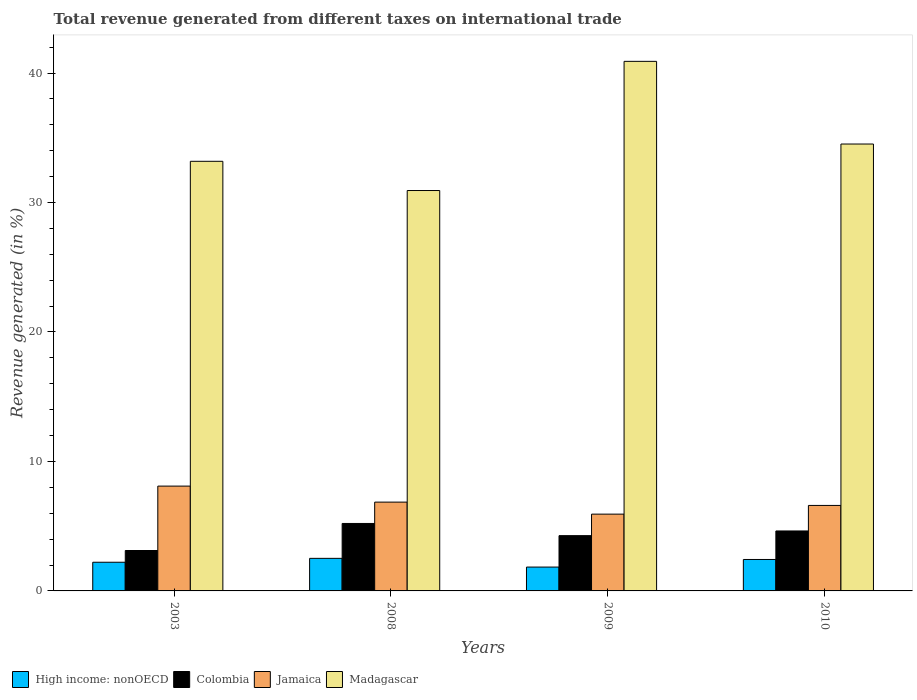How many groups of bars are there?
Keep it short and to the point. 4. Are the number of bars on each tick of the X-axis equal?
Your response must be concise. Yes. What is the label of the 1st group of bars from the left?
Make the answer very short. 2003. In how many cases, is the number of bars for a given year not equal to the number of legend labels?
Your answer should be compact. 0. What is the total revenue generated in Colombia in 2009?
Give a very brief answer. 4.27. Across all years, what is the maximum total revenue generated in Madagascar?
Offer a terse response. 40.9. Across all years, what is the minimum total revenue generated in Colombia?
Offer a very short reply. 3.12. In which year was the total revenue generated in High income: nonOECD maximum?
Give a very brief answer. 2008. What is the total total revenue generated in Colombia in the graph?
Your response must be concise. 17.23. What is the difference between the total revenue generated in High income: nonOECD in 2003 and that in 2010?
Your answer should be very brief. -0.21. What is the difference between the total revenue generated in Madagascar in 2010 and the total revenue generated in High income: nonOECD in 2003?
Offer a terse response. 32.3. What is the average total revenue generated in Madagascar per year?
Ensure brevity in your answer.  34.88. In the year 2009, what is the difference between the total revenue generated in Colombia and total revenue generated in Madagascar?
Give a very brief answer. -36.63. In how many years, is the total revenue generated in Jamaica greater than 22 %?
Your response must be concise. 0. What is the ratio of the total revenue generated in Madagascar in 2009 to that in 2010?
Your response must be concise. 1.18. Is the total revenue generated in Colombia in 2003 less than that in 2009?
Ensure brevity in your answer.  Yes. Is the difference between the total revenue generated in Colombia in 2008 and 2009 greater than the difference between the total revenue generated in Madagascar in 2008 and 2009?
Give a very brief answer. Yes. What is the difference between the highest and the second highest total revenue generated in High income: nonOECD?
Provide a succinct answer. 0.09. What is the difference between the highest and the lowest total revenue generated in Jamaica?
Make the answer very short. 2.16. In how many years, is the total revenue generated in High income: nonOECD greater than the average total revenue generated in High income: nonOECD taken over all years?
Provide a short and direct response. 2. Is the sum of the total revenue generated in Jamaica in 2009 and 2010 greater than the maximum total revenue generated in High income: nonOECD across all years?
Your answer should be very brief. Yes. What does the 1st bar from the left in 2003 represents?
Provide a succinct answer. High income: nonOECD. What does the 3rd bar from the right in 2010 represents?
Ensure brevity in your answer.  Colombia. Is it the case that in every year, the sum of the total revenue generated in Colombia and total revenue generated in Jamaica is greater than the total revenue generated in Madagascar?
Your answer should be very brief. No. Are all the bars in the graph horizontal?
Keep it short and to the point. No. Are the values on the major ticks of Y-axis written in scientific E-notation?
Offer a very short reply. No. Where does the legend appear in the graph?
Your answer should be compact. Bottom left. How many legend labels are there?
Provide a short and direct response. 4. How are the legend labels stacked?
Provide a short and direct response. Horizontal. What is the title of the graph?
Make the answer very short. Total revenue generated from different taxes on international trade. Does "Faeroe Islands" appear as one of the legend labels in the graph?
Your answer should be compact. No. What is the label or title of the X-axis?
Your response must be concise. Years. What is the label or title of the Y-axis?
Your answer should be compact. Revenue generated (in %). What is the Revenue generated (in %) of High income: nonOECD in 2003?
Ensure brevity in your answer.  2.21. What is the Revenue generated (in %) in Colombia in 2003?
Provide a succinct answer. 3.12. What is the Revenue generated (in %) of Jamaica in 2003?
Provide a short and direct response. 8.1. What is the Revenue generated (in %) in Madagascar in 2003?
Your answer should be compact. 33.18. What is the Revenue generated (in %) in High income: nonOECD in 2008?
Offer a terse response. 2.51. What is the Revenue generated (in %) of Colombia in 2008?
Give a very brief answer. 5.21. What is the Revenue generated (in %) of Jamaica in 2008?
Provide a succinct answer. 6.86. What is the Revenue generated (in %) in Madagascar in 2008?
Provide a succinct answer. 30.92. What is the Revenue generated (in %) of High income: nonOECD in 2009?
Ensure brevity in your answer.  1.84. What is the Revenue generated (in %) in Colombia in 2009?
Offer a terse response. 4.27. What is the Revenue generated (in %) of Jamaica in 2009?
Keep it short and to the point. 5.93. What is the Revenue generated (in %) in Madagascar in 2009?
Your answer should be compact. 40.9. What is the Revenue generated (in %) of High income: nonOECD in 2010?
Your response must be concise. 2.43. What is the Revenue generated (in %) in Colombia in 2010?
Provide a succinct answer. 4.63. What is the Revenue generated (in %) in Jamaica in 2010?
Offer a very short reply. 6.6. What is the Revenue generated (in %) of Madagascar in 2010?
Offer a very short reply. 34.52. Across all years, what is the maximum Revenue generated (in %) of High income: nonOECD?
Keep it short and to the point. 2.51. Across all years, what is the maximum Revenue generated (in %) in Colombia?
Provide a succinct answer. 5.21. Across all years, what is the maximum Revenue generated (in %) in Jamaica?
Make the answer very short. 8.1. Across all years, what is the maximum Revenue generated (in %) of Madagascar?
Your answer should be compact. 40.9. Across all years, what is the minimum Revenue generated (in %) of High income: nonOECD?
Provide a succinct answer. 1.84. Across all years, what is the minimum Revenue generated (in %) of Colombia?
Provide a succinct answer. 3.12. Across all years, what is the minimum Revenue generated (in %) in Jamaica?
Offer a very short reply. 5.93. Across all years, what is the minimum Revenue generated (in %) of Madagascar?
Offer a terse response. 30.92. What is the total Revenue generated (in %) of High income: nonOECD in the graph?
Your answer should be very brief. 9. What is the total Revenue generated (in %) in Colombia in the graph?
Your answer should be compact. 17.23. What is the total Revenue generated (in %) in Jamaica in the graph?
Keep it short and to the point. 27.49. What is the total Revenue generated (in %) in Madagascar in the graph?
Offer a terse response. 139.52. What is the difference between the Revenue generated (in %) of High income: nonOECD in 2003 and that in 2008?
Give a very brief answer. -0.3. What is the difference between the Revenue generated (in %) in Colombia in 2003 and that in 2008?
Provide a short and direct response. -2.09. What is the difference between the Revenue generated (in %) of Jamaica in 2003 and that in 2008?
Offer a very short reply. 1.24. What is the difference between the Revenue generated (in %) of Madagascar in 2003 and that in 2008?
Offer a very short reply. 2.26. What is the difference between the Revenue generated (in %) of High income: nonOECD in 2003 and that in 2009?
Provide a short and direct response. 0.37. What is the difference between the Revenue generated (in %) of Colombia in 2003 and that in 2009?
Keep it short and to the point. -1.15. What is the difference between the Revenue generated (in %) of Jamaica in 2003 and that in 2009?
Keep it short and to the point. 2.16. What is the difference between the Revenue generated (in %) of Madagascar in 2003 and that in 2009?
Give a very brief answer. -7.72. What is the difference between the Revenue generated (in %) in High income: nonOECD in 2003 and that in 2010?
Offer a very short reply. -0.21. What is the difference between the Revenue generated (in %) of Colombia in 2003 and that in 2010?
Your answer should be compact. -1.51. What is the difference between the Revenue generated (in %) in Jamaica in 2003 and that in 2010?
Give a very brief answer. 1.49. What is the difference between the Revenue generated (in %) in Madagascar in 2003 and that in 2010?
Provide a short and direct response. -1.34. What is the difference between the Revenue generated (in %) of High income: nonOECD in 2008 and that in 2009?
Provide a succinct answer. 0.67. What is the difference between the Revenue generated (in %) of Colombia in 2008 and that in 2009?
Make the answer very short. 0.94. What is the difference between the Revenue generated (in %) of Jamaica in 2008 and that in 2009?
Your answer should be compact. 0.93. What is the difference between the Revenue generated (in %) in Madagascar in 2008 and that in 2009?
Your response must be concise. -9.98. What is the difference between the Revenue generated (in %) in High income: nonOECD in 2008 and that in 2010?
Ensure brevity in your answer.  0.09. What is the difference between the Revenue generated (in %) in Colombia in 2008 and that in 2010?
Offer a terse response. 0.58. What is the difference between the Revenue generated (in %) of Jamaica in 2008 and that in 2010?
Provide a short and direct response. 0.26. What is the difference between the Revenue generated (in %) in Madagascar in 2008 and that in 2010?
Ensure brevity in your answer.  -3.59. What is the difference between the Revenue generated (in %) of High income: nonOECD in 2009 and that in 2010?
Provide a short and direct response. -0.59. What is the difference between the Revenue generated (in %) in Colombia in 2009 and that in 2010?
Offer a very short reply. -0.36. What is the difference between the Revenue generated (in %) in Jamaica in 2009 and that in 2010?
Your answer should be compact. -0.67. What is the difference between the Revenue generated (in %) in Madagascar in 2009 and that in 2010?
Provide a short and direct response. 6.38. What is the difference between the Revenue generated (in %) in High income: nonOECD in 2003 and the Revenue generated (in %) in Colombia in 2008?
Keep it short and to the point. -3. What is the difference between the Revenue generated (in %) in High income: nonOECD in 2003 and the Revenue generated (in %) in Jamaica in 2008?
Your response must be concise. -4.64. What is the difference between the Revenue generated (in %) of High income: nonOECD in 2003 and the Revenue generated (in %) of Madagascar in 2008?
Provide a short and direct response. -28.71. What is the difference between the Revenue generated (in %) of Colombia in 2003 and the Revenue generated (in %) of Jamaica in 2008?
Make the answer very short. -3.74. What is the difference between the Revenue generated (in %) of Colombia in 2003 and the Revenue generated (in %) of Madagascar in 2008?
Offer a very short reply. -27.8. What is the difference between the Revenue generated (in %) in Jamaica in 2003 and the Revenue generated (in %) in Madagascar in 2008?
Keep it short and to the point. -22.83. What is the difference between the Revenue generated (in %) of High income: nonOECD in 2003 and the Revenue generated (in %) of Colombia in 2009?
Offer a terse response. -2.05. What is the difference between the Revenue generated (in %) of High income: nonOECD in 2003 and the Revenue generated (in %) of Jamaica in 2009?
Your response must be concise. -3.72. What is the difference between the Revenue generated (in %) in High income: nonOECD in 2003 and the Revenue generated (in %) in Madagascar in 2009?
Offer a terse response. -38.69. What is the difference between the Revenue generated (in %) in Colombia in 2003 and the Revenue generated (in %) in Jamaica in 2009?
Your answer should be compact. -2.81. What is the difference between the Revenue generated (in %) of Colombia in 2003 and the Revenue generated (in %) of Madagascar in 2009?
Provide a short and direct response. -37.78. What is the difference between the Revenue generated (in %) in Jamaica in 2003 and the Revenue generated (in %) in Madagascar in 2009?
Your answer should be very brief. -32.8. What is the difference between the Revenue generated (in %) of High income: nonOECD in 2003 and the Revenue generated (in %) of Colombia in 2010?
Offer a very short reply. -2.42. What is the difference between the Revenue generated (in %) in High income: nonOECD in 2003 and the Revenue generated (in %) in Jamaica in 2010?
Offer a very short reply. -4.39. What is the difference between the Revenue generated (in %) in High income: nonOECD in 2003 and the Revenue generated (in %) in Madagascar in 2010?
Make the answer very short. -32.3. What is the difference between the Revenue generated (in %) in Colombia in 2003 and the Revenue generated (in %) in Jamaica in 2010?
Your response must be concise. -3.48. What is the difference between the Revenue generated (in %) in Colombia in 2003 and the Revenue generated (in %) in Madagascar in 2010?
Provide a short and direct response. -31.39. What is the difference between the Revenue generated (in %) in Jamaica in 2003 and the Revenue generated (in %) in Madagascar in 2010?
Make the answer very short. -26.42. What is the difference between the Revenue generated (in %) in High income: nonOECD in 2008 and the Revenue generated (in %) in Colombia in 2009?
Make the answer very short. -1.75. What is the difference between the Revenue generated (in %) in High income: nonOECD in 2008 and the Revenue generated (in %) in Jamaica in 2009?
Offer a very short reply. -3.42. What is the difference between the Revenue generated (in %) of High income: nonOECD in 2008 and the Revenue generated (in %) of Madagascar in 2009?
Your response must be concise. -38.38. What is the difference between the Revenue generated (in %) in Colombia in 2008 and the Revenue generated (in %) in Jamaica in 2009?
Provide a short and direct response. -0.72. What is the difference between the Revenue generated (in %) of Colombia in 2008 and the Revenue generated (in %) of Madagascar in 2009?
Your answer should be very brief. -35.69. What is the difference between the Revenue generated (in %) of Jamaica in 2008 and the Revenue generated (in %) of Madagascar in 2009?
Ensure brevity in your answer.  -34.04. What is the difference between the Revenue generated (in %) of High income: nonOECD in 2008 and the Revenue generated (in %) of Colombia in 2010?
Ensure brevity in your answer.  -2.12. What is the difference between the Revenue generated (in %) of High income: nonOECD in 2008 and the Revenue generated (in %) of Jamaica in 2010?
Ensure brevity in your answer.  -4.09. What is the difference between the Revenue generated (in %) of High income: nonOECD in 2008 and the Revenue generated (in %) of Madagascar in 2010?
Keep it short and to the point. -32. What is the difference between the Revenue generated (in %) of Colombia in 2008 and the Revenue generated (in %) of Jamaica in 2010?
Your response must be concise. -1.39. What is the difference between the Revenue generated (in %) in Colombia in 2008 and the Revenue generated (in %) in Madagascar in 2010?
Keep it short and to the point. -29.3. What is the difference between the Revenue generated (in %) of Jamaica in 2008 and the Revenue generated (in %) of Madagascar in 2010?
Your answer should be compact. -27.66. What is the difference between the Revenue generated (in %) in High income: nonOECD in 2009 and the Revenue generated (in %) in Colombia in 2010?
Offer a very short reply. -2.79. What is the difference between the Revenue generated (in %) of High income: nonOECD in 2009 and the Revenue generated (in %) of Jamaica in 2010?
Your answer should be compact. -4.76. What is the difference between the Revenue generated (in %) in High income: nonOECD in 2009 and the Revenue generated (in %) in Madagascar in 2010?
Offer a very short reply. -32.67. What is the difference between the Revenue generated (in %) of Colombia in 2009 and the Revenue generated (in %) of Jamaica in 2010?
Provide a short and direct response. -2.33. What is the difference between the Revenue generated (in %) of Colombia in 2009 and the Revenue generated (in %) of Madagascar in 2010?
Provide a succinct answer. -30.25. What is the difference between the Revenue generated (in %) in Jamaica in 2009 and the Revenue generated (in %) in Madagascar in 2010?
Keep it short and to the point. -28.58. What is the average Revenue generated (in %) of High income: nonOECD per year?
Your answer should be very brief. 2.25. What is the average Revenue generated (in %) of Colombia per year?
Offer a terse response. 4.31. What is the average Revenue generated (in %) of Jamaica per year?
Ensure brevity in your answer.  6.87. What is the average Revenue generated (in %) in Madagascar per year?
Your response must be concise. 34.88. In the year 2003, what is the difference between the Revenue generated (in %) in High income: nonOECD and Revenue generated (in %) in Colombia?
Offer a terse response. -0.91. In the year 2003, what is the difference between the Revenue generated (in %) of High income: nonOECD and Revenue generated (in %) of Jamaica?
Ensure brevity in your answer.  -5.88. In the year 2003, what is the difference between the Revenue generated (in %) in High income: nonOECD and Revenue generated (in %) in Madagascar?
Offer a terse response. -30.97. In the year 2003, what is the difference between the Revenue generated (in %) of Colombia and Revenue generated (in %) of Jamaica?
Make the answer very short. -4.97. In the year 2003, what is the difference between the Revenue generated (in %) of Colombia and Revenue generated (in %) of Madagascar?
Your answer should be compact. -30.06. In the year 2003, what is the difference between the Revenue generated (in %) of Jamaica and Revenue generated (in %) of Madagascar?
Your response must be concise. -25.08. In the year 2008, what is the difference between the Revenue generated (in %) of High income: nonOECD and Revenue generated (in %) of Colombia?
Offer a very short reply. -2.7. In the year 2008, what is the difference between the Revenue generated (in %) in High income: nonOECD and Revenue generated (in %) in Jamaica?
Make the answer very short. -4.34. In the year 2008, what is the difference between the Revenue generated (in %) in High income: nonOECD and Revenue generated (in %) in Madagascar?
Give a very brief answer. -28.41. In the year 2008, what is the difference between the Revenue generated (in %) of Colombia and Revenue generated (in %) of Jamaica?
Your answer should be compact. -1.65. In the year 2008, what is the difference between the Revenue generated (in %) in Colombia and Revenue generated (in %) in Madagascar?
Your answer should be very brief. -25.71. In the year 2008, what is the difference between the Revenue generated (in %) of Jamaica and Revenue generated (in %) of Madagascar?
Give a very brief answer. -24.07. In the year 2009, what is the difference between the Revenue generated (in %) in High income: nonOECD and Revenue generated (in %) in Colombia?
Offer a very short reply. -2.43. In the year 2009, what is the difference between the Revenue generated (in %) of High income: nonOECD and Revenue generated (in %) of Jamaica?
Offer a terse response. -4.09. In the year 2009, what is the difference between the Revenue generated (in %) of High income: nonOECD and Revenue generated (in %) of Madagascar?
Provide a succinct answer. -39.06. In the year 2009, what is the difference between the Revenue generated (in %) of Colombia and Revenue generated (in %) of Jamaica?
Provide a succinct answer. -1.66. In the year 2009, what is the difference between the Revenue generated (in %) of Colombia and Revenue generated (in %) of Madagascar?
Provide a short and direct response. -36.63. In the year 2009, what is the difference between the Revenue generated (in %) in Jamaica and Revenue generated (in %) in Madagascar?
Provide a short and direct response. -34.97. In the year 2010, what is the difference between the Revenue generated (in %) in High income: nonOECD and Revenue generated (in %) in Colombia?
Ensure brevity in your answer.  -2.2. In the year 2010, what is the difference between the Revenue generated (in %) of High income: nonOECD and Revenue generated (in %) of Jamaica?
Provide a succinct answer. -4.17. In the year 2010, what is the difference between the Revenue generated (in %) in High income: nonOECD and Revenue generated (in %) in Madagascar?
Offer a very short reply. -32.09. In the year 2010, what is the difference between the Revenue generated (in %) of Colombia and Revenue generated (in %) of Jamaica?
Keep it short and to the point. -1.97. In the year 2010, what is the difference between the Revenue generated (in %) in Colombia and Revenue generated (in %) in Madagascar?
Offer a very short reply. -29.88. In the year 2010, what is the difference between the Revenue generated (in %) in Jamaica and Revenue generated (in %) in Madagascar?
Ensure brevity in your answer.  -27.91. What is the ratio of the Revenue generated (in %) of High income: nonOECD in 2003 to that in 2008?
Offer a terse response. 0.88. What is the ratio of the Revenue generated (in %) of Colombia in 2003 to that in 2008?
Your answer should be compact. 0.6. What is the ratio of the Revenue generated (in %) in Jamaica in 2003 to that in 2008?
Ensure brevity in your answer.  1.18. What is the ratio of the Revenue generated (in %) in Madagascar in 2003 to that in 2008?
Your response must be concise. 1.07. What is the ratio of the Revenue generated (in %) in High income: nonOECD in 2003 to that in 2009?
Make the answer very short. 1.2. What is the ratio of the Revenue generated (in %) in Colombia in 2003 to that in 2009?
Your answer should be very brief. 0.73. What is the ratio of the Revenue generated (in %) of Jamaica in 2003 to that in 2009?
Your response must be concise. 1.36. What is the ratio of the Revenue generated (in %) of Madagascar in 2003 to that in 2009?
Provide a short and direct response. 0.81. What is the ratio of the Revenue generated (in %) in High income: nonOECD in 2003 to that in 2010?
Make the answer very short. 0.91. What is the ratio of the Revenue generated (in %) in Colombia in 2003 to that in 2010?
Ensure brevity in your answer.  0.67. What is the ratio of the Revenue generated (in %) in Jamaica in 2003 to that in 2010?
Offer a very short reply. 1.23. What is the ratio of the Revenue generated (in %) of Madagascar in 2003 to that in 2010?
Your answer should be very brief. 0.96. What is the ratio of the Revenue generated (in %) in High income: nonOECD in 2008 to that in 2009?
Your response must be concise. 1.37. What is the ratio of the Revenue generated (in %) in Colombia in 2008 to that in 2009?
Keep it short and to the point. 1.22. What is the ratio of the Revenue generated (in %) of Jamaica in 2008 to that in 2009?
Your answer should be very brief. 1.16. What is the ratio of the Revenue generated (in %) of Madagascar in 2008 to that in 2009?
Give a very brief answer. 0.76. What is the ratio of the Revenue generated (in %) in High income: nonOECD in 2008 to that in 2010?
Offer a terse response. 1.04. What is the ratio of the Revenue generated (in %) in Colombia in 2008 to that in 2010?
Provide a succinct answer. 1.13. What is the ratio of the Revenue generated (in %) of Jamaica in 2008 to that in 2010?
Keep it short and to the point. 1.04. What is the ratio of the Revenue generated (in %) in Madagascar in 2008 to that in 2010?
Offer a very short reply. 0.9. What is the ratio of the Revenue generated (in %) in High income: nonOECD in 2009 to that in 2010?
Make the answer very short. 0.76. What is the ratio of the Revenue generated (in %) of Colombia in 2009 to that in 2010?
Your response must be concise. 0.92. What is the ratio of the Revenue generated (in %) of Jamaica in 2009 to that in 2010?
Provide a succinct answer. 0.9. What is the ratio of the Revenue generated (in %) in Madagascar in 2009 to that in 2010?
Ensure brevity in your answer.  1.19. What is the difference between the highest and the second highest Revenue generated (in %) in High income: nonOECD?
Make the answer very short. 0.09. What is the difference between the highest and the second highest Revenue generated (in %) of Colombia?
Your response must be concise. 0.58. What is the difference between the highest and the second highest Revenue generated (in %) of Jamaica?
Your answer should be very brief. 1.24. What is the difference between the highest and the second highest Revenue generated (in %) of Madagascar?
Your answer should be very brief. 6.38. What is the difference between the highest and the lowest Revenue generated (in %) of High income: nonOECD?
Give a very brief answer. 0.67. What is the difference between the highest and the lowest Revenue generated (in %) of Colombia?
Make the answer very short. 2.09. What is the difference between the highest and the lowest Revenue generated (in %) of Jamaica?
Ensure brevity in your answer.  2.16. What is the difference between the highest and the lowest Revenue generated (in %) of Madagascar?
Your answer should be very brief. 9.98. 